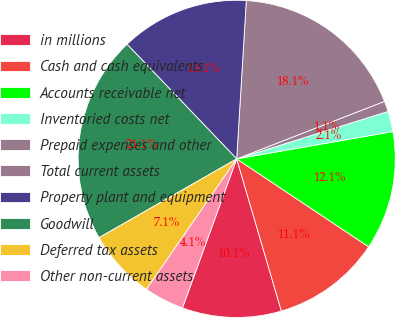Convert chart to OTSL. <chart><loc_0><loc_0><loc_500><loc_500><pie_chart><fcel>in millions<fcel>Cash and cash equivalents<fcel>Accounts receivable net<fcel>Inventoried costs net<fcel>Prepaid expenses and other<fcel>Total current assets<fcel>Property plant and equipment<fcel>Goodwill<fcel>Deferred tax assets<fcel>Other non-current assets<nl><fcel>10.1%<fcel>11.1%<fcel>12.11%<fcel>2.08%<fcel>1.07%<fcel>18.13%<fcel>13.11%<fcel>21.13%<fcel>7.09%<fcel>4.08%<nl></chart> 